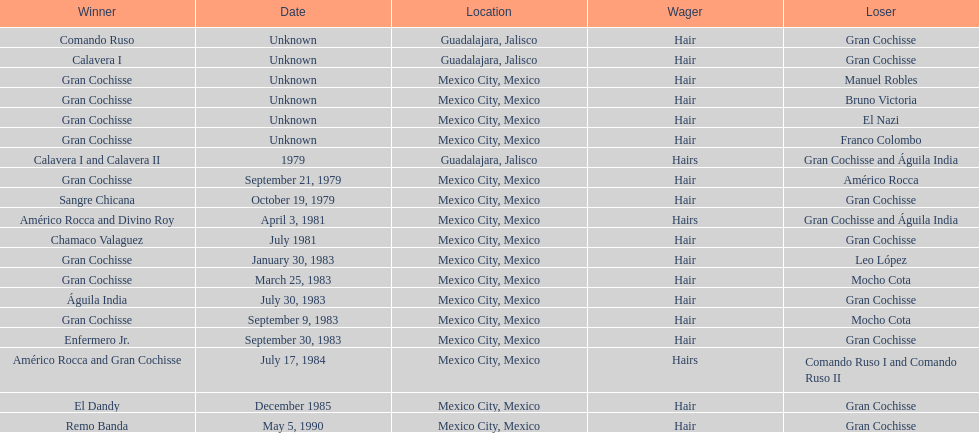How many times has the wager been hair? 16. 